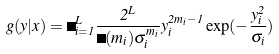Convert formula to latex. <formula><loc_0><loc_0><loc_500><loc_500>g ( y | x ) = \Pi _ { i = 1 } ^ { L } \frac { 2 ^ { L } } { \Gamma ( m _ { i } ) \sigma _ { i } ^ { m _ { i } } } y _ { i } ^ { 2 m _ { i } - 1 } \exp ( - \frac { y _ { i } ^ { 2 } } { \sigma _ { i } } )</formula> 